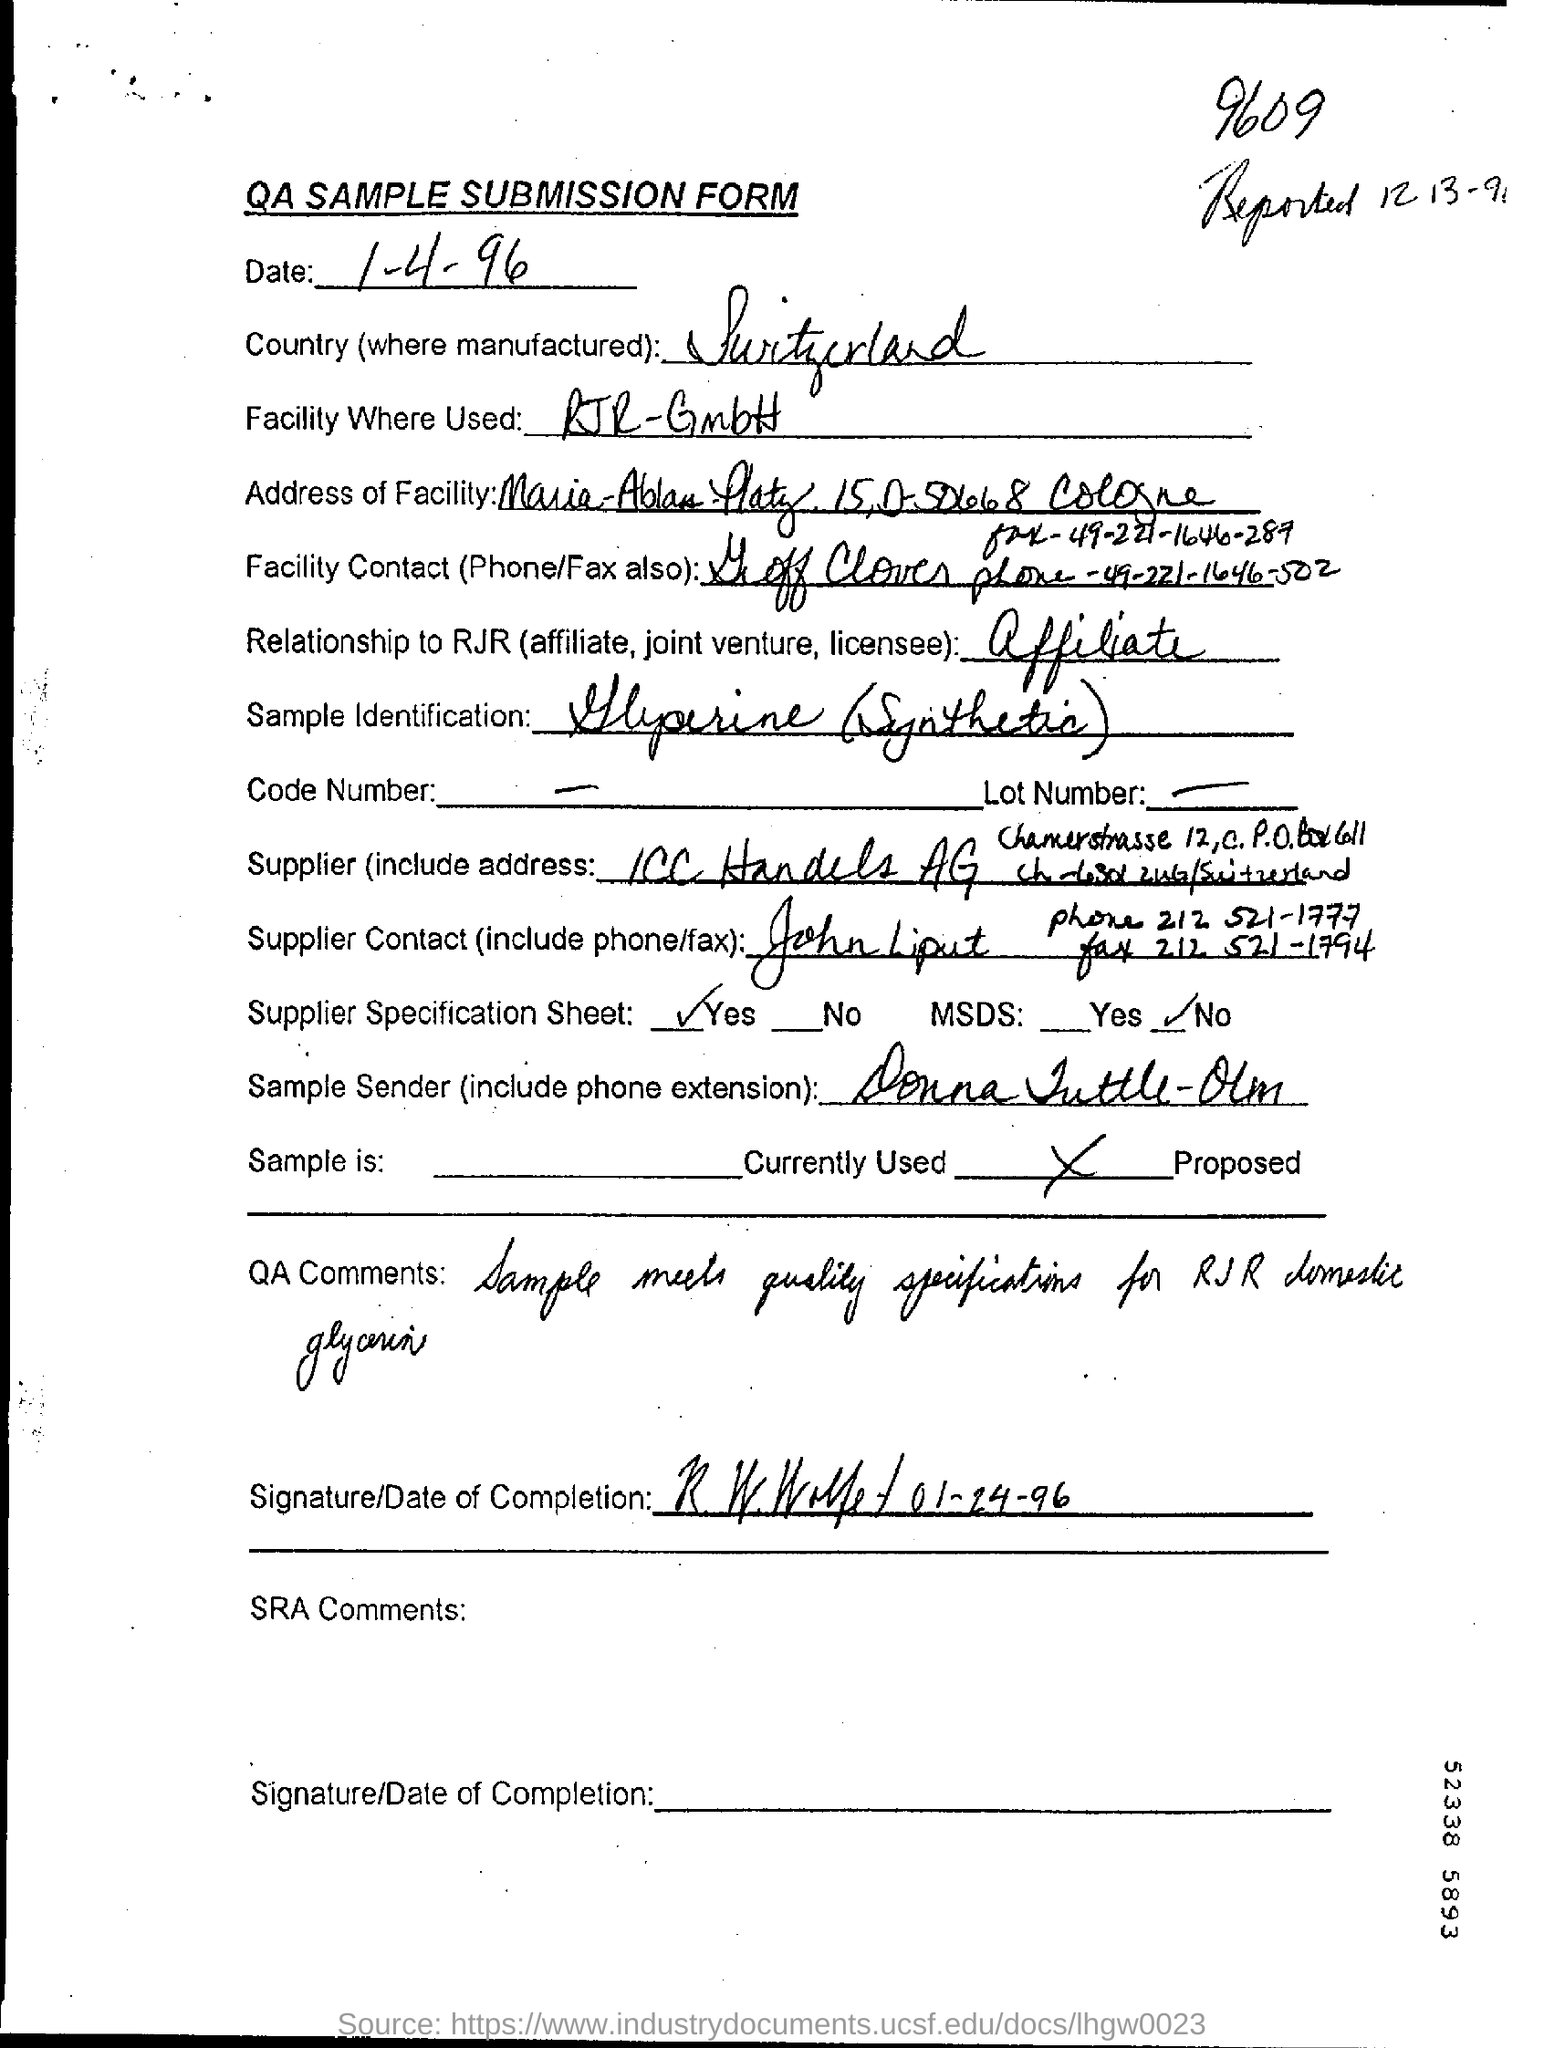Identify some key points in this picture. Switzerland is the name of the country mentioned. The date mentioned is April 1, 1996. The heading of the document is 'QA SAMPLE SUBMISSION FORM.' 